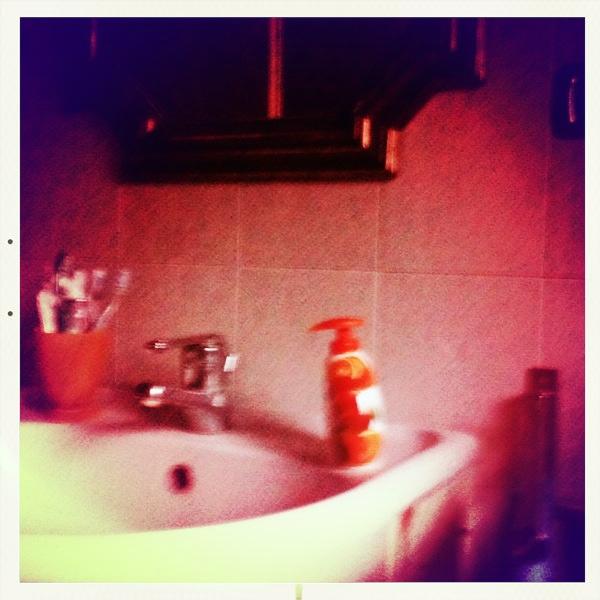What kind of room is this?
Answer briefly. Bathroom. Is the photo blurry?
Quick response, please. Yes. Is the water running from the faucet?
Concise answer only. No. 